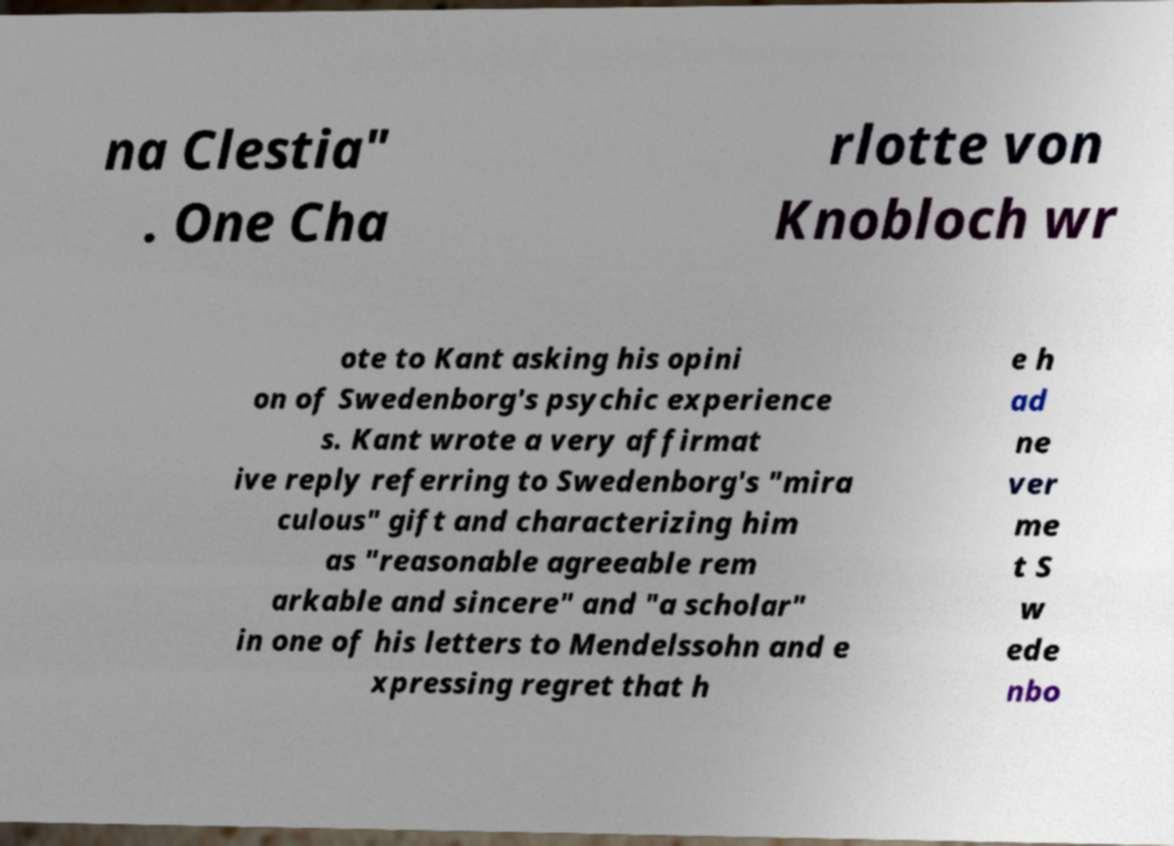Can you accurately transcribe the text from the provided image for me? na Clestia" . One Cha rlotte von Knobloch wr ote to Kant asking his opini on of Swedenborg's psychic experience s. Kant wrote a very affirmat ive reply referring to Swedenborg's "mira culous" gift and characterizing him as "reasonable agreeable rem arkable and sincere" and "a scholar" in one of his letters to Mendelssohn and e xpressing regret that h e h ad ne ver me t S w ede nbo 